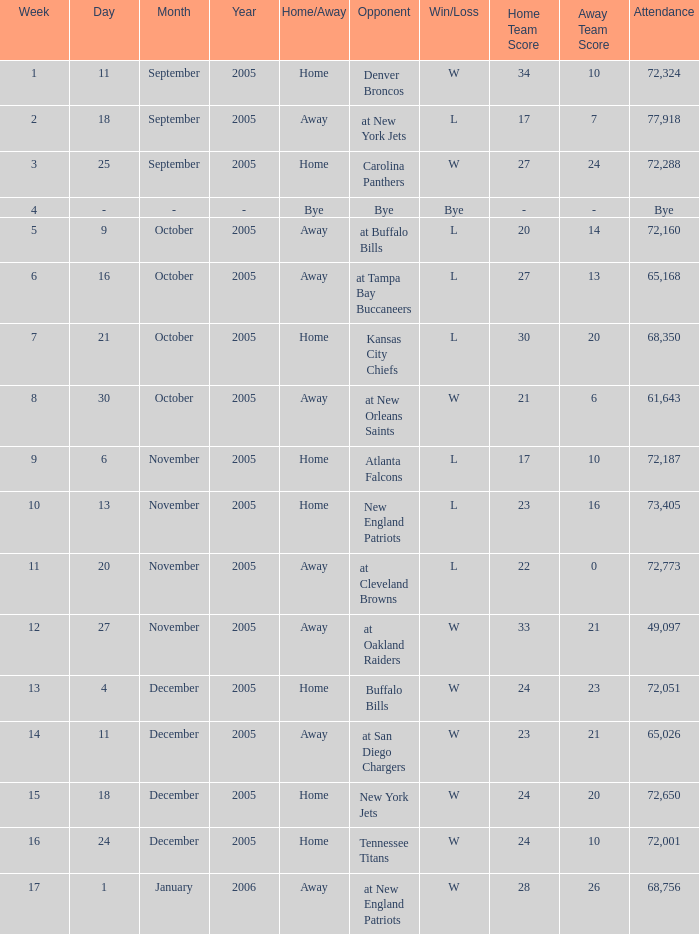What is the Date of the game with an attendance of 72,051 after Week 9? December 4, 2005. 